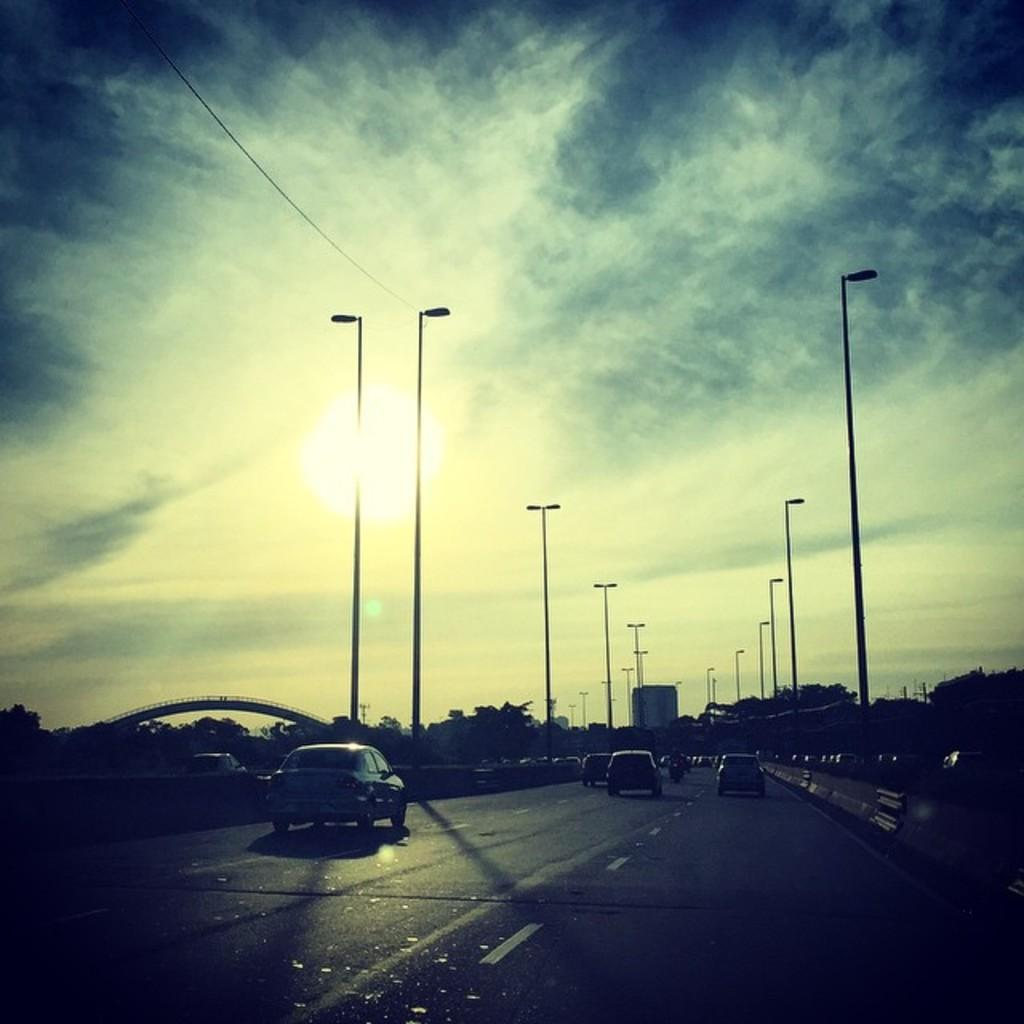What can be seen on the road in the image? There are vehicles on the road in the image. What structures are present alongside the road? Light poles are present in the image. What type of man-made structure is visible in the image? There is at least one building in the image. What type of infrastructure is visible in the image? A bridge is visible in the image. What type of natural elements are present in the image? Trees are present in the image. What part of the natural environment is visible in the background of the image? The sky is visible in the background of the image. What type of seat can be seen on the bridge in the image? There is no seat visible on the bridge in the image. What type of pleasure can be derived from the image? The image does not convey any specific pleasure or emotion; it is a neutral representation of the scene. 